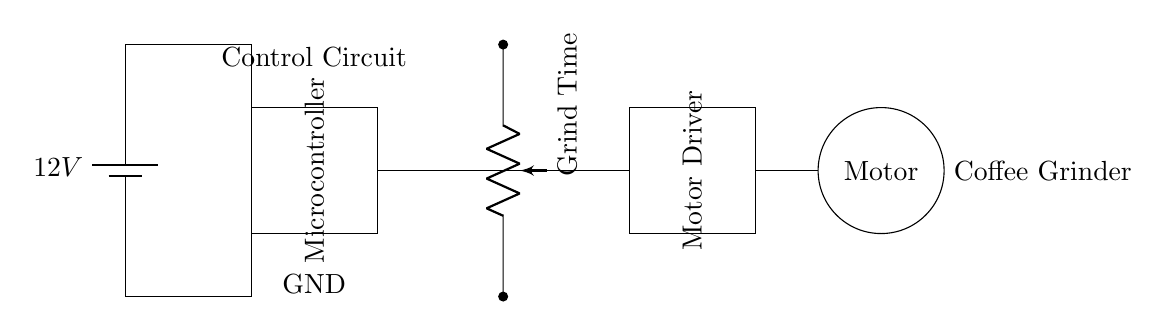What is the voltage of this circuit? The circuit is powered by a battery labeled as 12V, which indicates the voltage supplied to the components.
Answer: 12V What component adjusts the grind time? The circuit includes a potentiometer indicated with the label "Grind Time", which allows users to change the duration of the grinding process.
Answer: Potentiometer What type of motor is used in the coffee grinder? The coffee grinder motor is represented as a circle labeled "Motor," signifying that it is indeed a motor used for the grinding action.
Answer: Motor How many main components are there in the control circuit? The circuit has four main components: a battery, a microcontroller, a motor driver, and a motor, which are essential for its operation.
Answer: Four What is the role of the microcontroller in this circuit? The microcontroller processes the input from the potentiometer to control the motor driver, thus regulating the grinding time based on user input.
Answer: Control What is the connection type between the battery and microcontroller? The connection drawn is a direct line from the battery to the microcontroller, representing a simple power connection that provides voltage.
Answer: Direct What does the label "GND" indicate in this circuit? “GND” signifies the ground connection, which is a common return path for electric current and is critical for circuit functionality.
Answer: Ground 